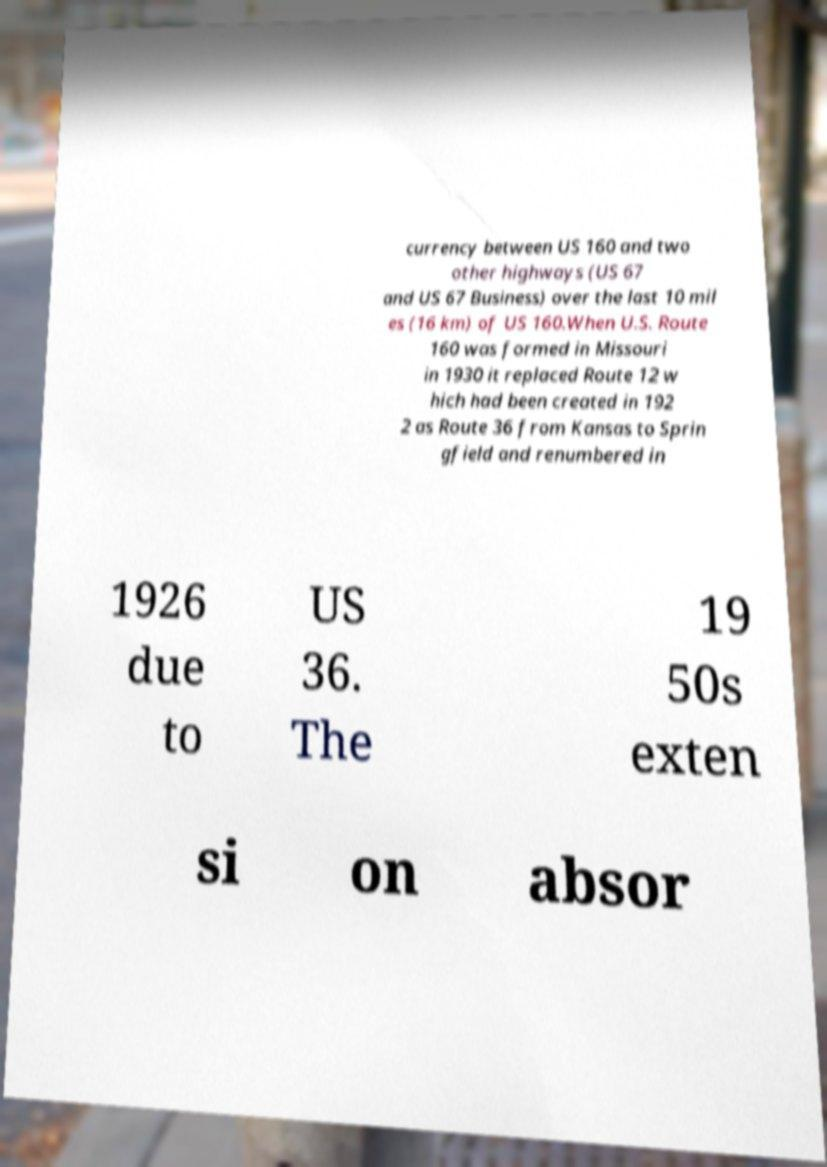I need the written content from this picture converted into text. Can you do that? currency between US 160 and two other highways (US 67 and US 67 Business) over the last 10 mil es (16 km) of US 160.When U.S. Route 160 was formed in Missouri in 1930 it replaced Route 12 w hich had been created in 192 2 as Route 36 from Kansas to Sprin gfield and renumbered in 1926 due to US 36. The 19 50s exten si on absor 